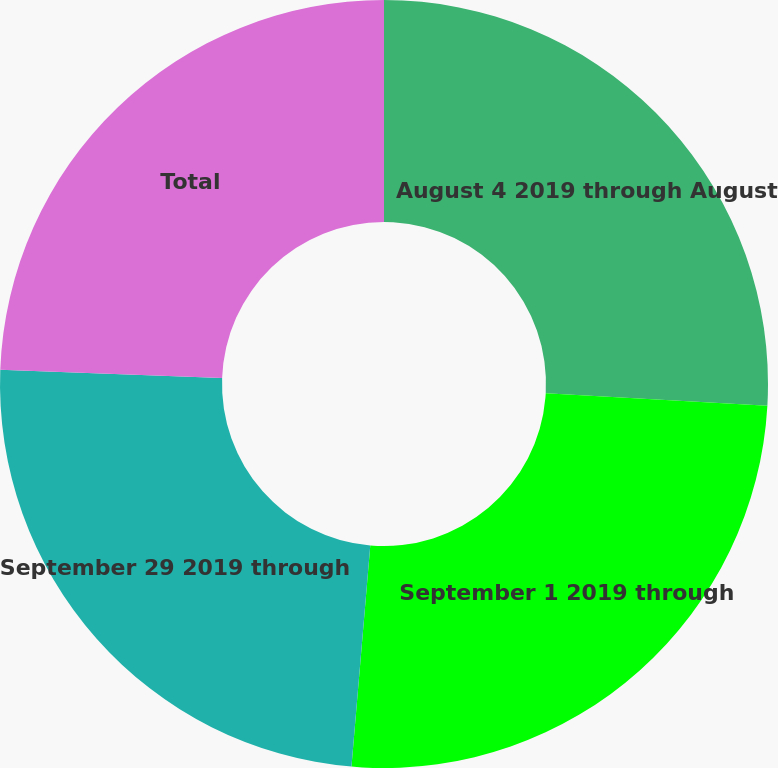Convert chart to OTSL. <chart><loc_0><loc_0><loc_500><loc_500><pie_chart><fcel>August 4 2019 through August<fcel>September 1 2019 through<fcel>September 29 2019 through<fcel>Total<nl><fcel>25.9%<fcel>25.45%<fcel>24.24%<fcel>24.41%<nl></chart> 